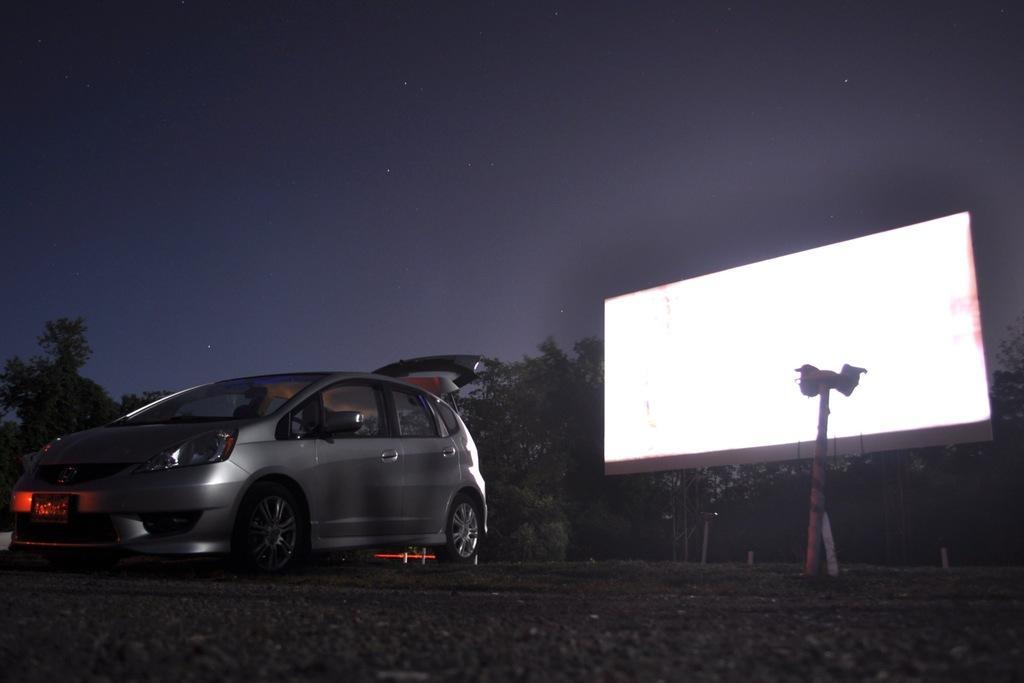How would you summarize this image in a sentence or two? In this image, we can see a vehicle. We can see the ground with some objects. There are a few trees, poles. We can see a board with some light. We can see the sky. 